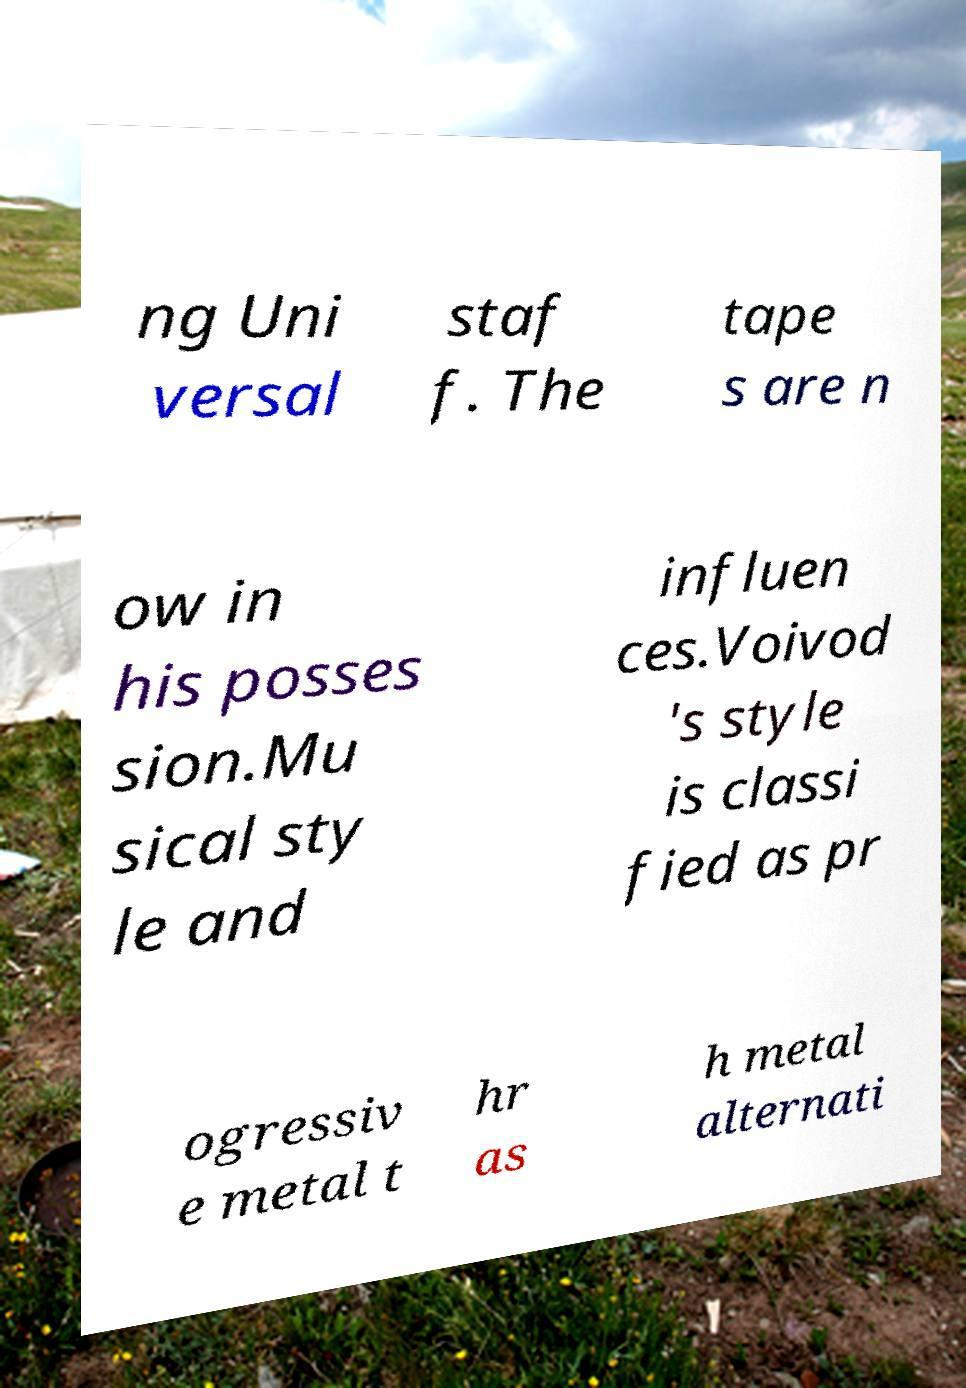Could you extract and type out the text from this image? ng Uni versal staf f. The tape s are n ow in his posses sion.Mu sical sty le and influen ces.Voivod 's style is classi fied as pr ogressiv e metal t hr as h metal alternati 